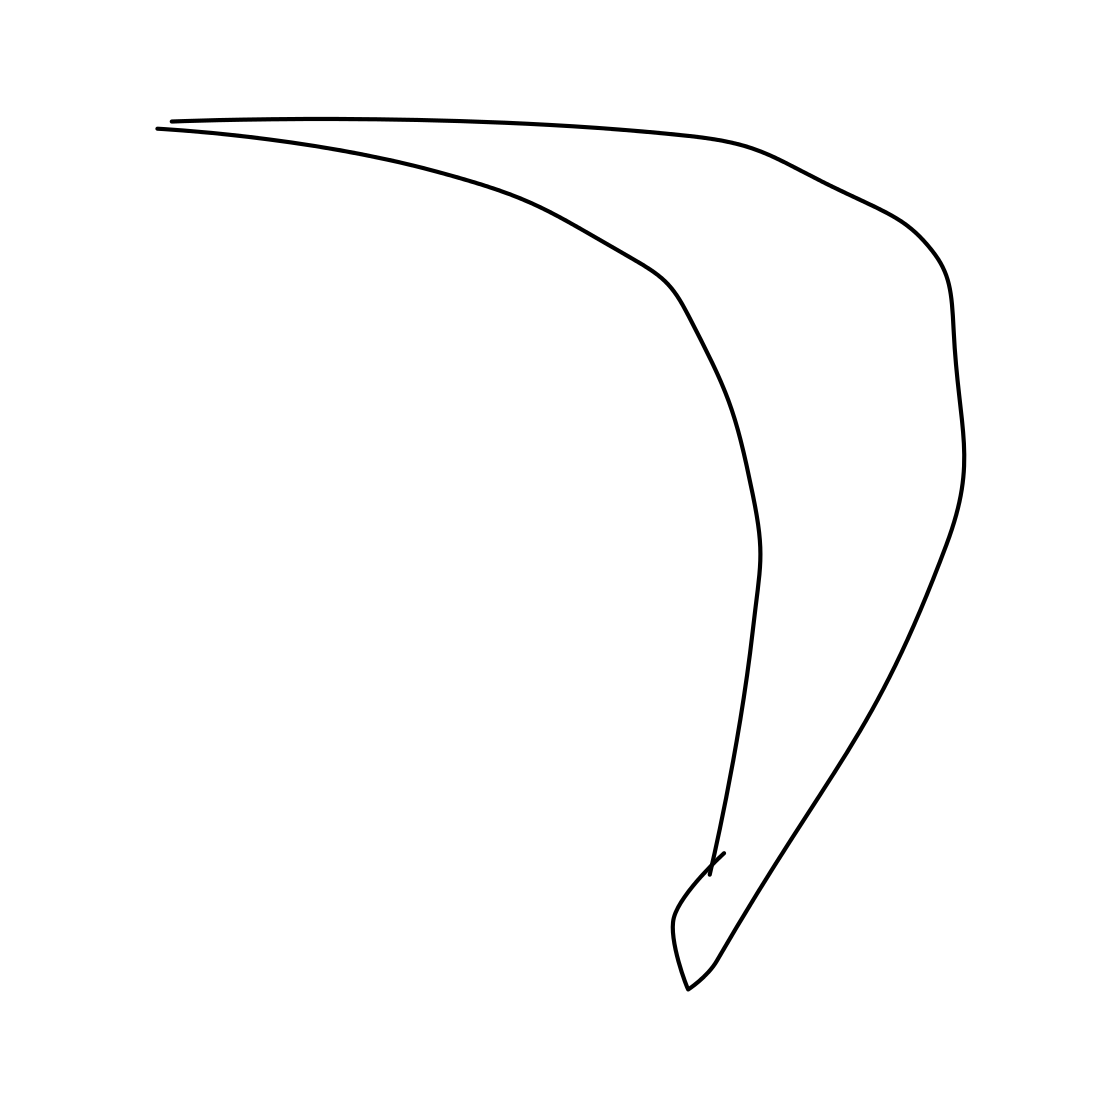Is this a tiger in the image? No, the image does not show a tiger. What you're seeing is merely a simple, abstract line drawing that does not represent any particular animal or object. 